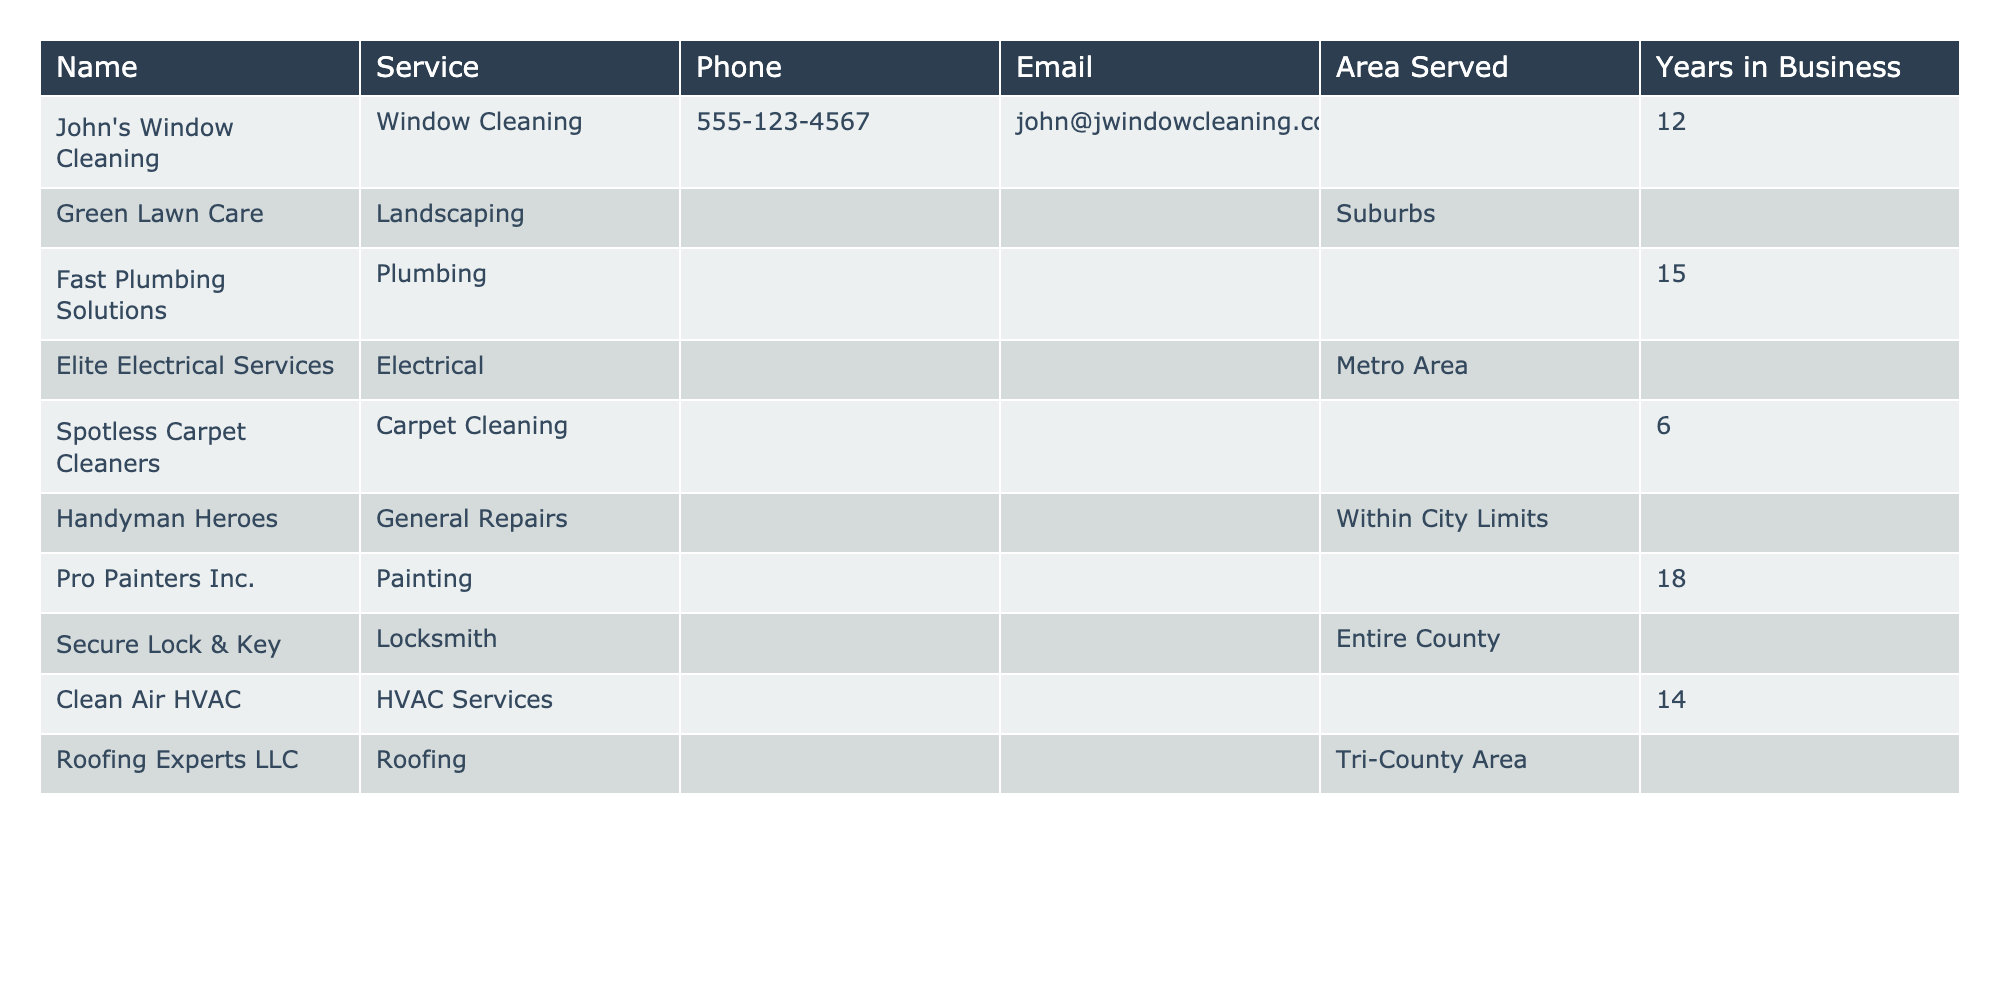What is the phone number for Clean Air HVAC? The table lists "55-951-7532" as the phone number for Clean Air HVAC under the Phone column.
Answer: 555-951-7532 Which service has been in business for the longest time? Looking at the Years in Business column, Secure Lock & Key has 25 years, which is greater than any other provider listed.
Answer: Secure Lock & Key How many total years of experience do all the service providers have combined? Adding up the Years in Business: 12 + 8 + 15 + 20 + 6 + 10 + 18 + 25 + 14 + 22 =  155 years in total.
Answer: 155 Is Fast Plumbing Solutions available for the entire county? Fast Plumbing Solutions is listed as serving Citywide, which means it does not serve the entire county.
Answer: No What service is offered by the provider with the second-longest time in business? Secure Lock & Key offers locksmith services and has the longest time in business. The second-longest is Roofing Experts LLC which offers roofing services.
Answer: Roofing What is the area served by Pro Painters Inc.? Pro Painters Inc. serves a 30-mile radius, which is specified in the Area Served column.
Answer: 30-mile Radius Which provider is listed under General Repairs? Handyman Heroes is the provider listed under General Repairs in the Service column.
Answer: Handyman Heroes How many of the service providers have more than 15 years of experience? Counting those with more than 15 years: Fast Plumbing Solutions (15), Elite Electrical Services (20), Secure Lock & Key (25), and Roofing Experts LLC (22) gives a total of 4.
Answer: 4 Is Spotless Carpet Cleaners the only provider offering carpet cleaning services? Yes, Spotless Carpet Cleaners is the only provider listed that offers carpet cleaning services as per the Service column.
Answer: Yes Which service provider's email address starts with "contact"? The email address for Elite Electrical Services starts with "contact" as shown in the Email column.
Answer: Elite Electrical Services 